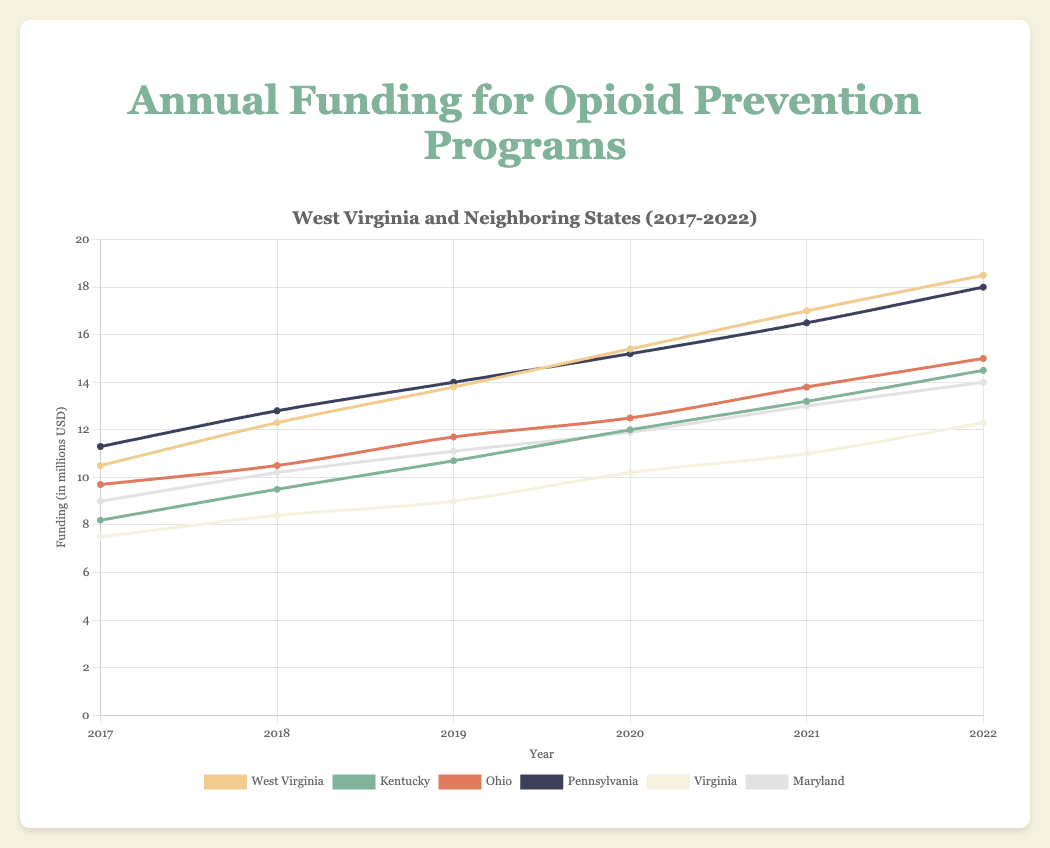Which state has seen the highest increase in funding from 2017 to 2022? The highest increase can be identified by calculating the difference in funding between 2022 and 2017 for each state. West Virginia: 18.5 - 10.5 = 8.0, Kentucky: 14.5 - 8.2 = 6.3, Ohio: 15.0 - 9.7 = 5.3, Pennsylvania: 18.0 - 11.3 = 6.7, Virginia: 12.3 - 7.5 = 4.8, Maryland: 14.0 - 9.0 = 5.0. West Virginia has the highest increase of 8.0 million USD.
Answer: West Virginia Which state had the lowest funding in 2019? Look at the data points for each state in the year 2019. West Virginia: 13.8, Kentucky: 10.7, Ohio: 11.7, Pennsylvania: 14.0, Virginia: 9.0, Maryland: 11.1. Virginia had the lowest funding with 9.0 million USD.
Answer: Virginia How does the funding change in Maryland from 2017 to 2022 compare to the funding change in Ohio from 2017 to 2022? Calculate the funding change for both states. For Maryland, the change is 14.0 - 9.0 = 5.0. For Ohio, the change is 15.0 - 9.7 = 5.3. Compare these values. Ohio had a slightly higher increase in funding (5.3 million USD) compared to Maryland (5.0 million USD).
Answer: Ohio had a higher increase What is the average funding for West Virginia over the period 2017-2022? To find the average funding, sum the funding amounts for West Virginia over the six years and divide by the number of years: (10.5 + 12.3 + 13.8 + 15.4 + 17.0 + 18.5) / 6 = 87.5 / 6 = 14.58 million USD.
Answer: 14.58 million USD In which year did Pennsylvania first surpass 15 million USD in funding? Check the data for Pennsylvania over the years: 2017: 11.3, 2018: 12.8, 2019: 14.0, 2020: 15.2, 2021: 16.5, 2022: 18.0. Pennsylvania first surpassed 15 million USD in 2020.
Answer: 2020 Between 2020 and 2021, which state had the largest increase in funding? Determine the increase in funding for each state between 2020 and 2021. West Virginia: 17.0 - 15.4 = 1.6, Kentucky: 13.2 - 12.0 = 1.2, Ohio: 13.8 - 12.5 = 1.3, Pennsylvania: 16.5 - 15.2 = 1.3, Virginia: 11.0 - 10.2 = 0.8, Maryland: 13.0 - 11.9 = 1.1. West Virginia had the largest increase of 1.6 million USD.
Answer: West Virginia How many states had more than 12 million USD in funding by the year 2021? Compare the funding amounts for each state in 2021. West Virginia: 17.0, Kentucky: 13.2, Ohio: 13.8, Pennsylvania: 16.5, Virginia: 11.0, Maryland: 13.0. Five states (West Virginia, Kentucky, Ohio, Pennsylvania, Maryland) had more than 12 million USD in funding.
Answer: 5 states Which state had the steady rise in funding from 2017 to 2022 without any decrease in any year? Check the funding data for each state year by year to see if there are any decreases. All states show a steady increase in funding: West Virginia, Kentucky, Ohio, Pennsylvania, Virginia, and Maryland.
Answer: All states 